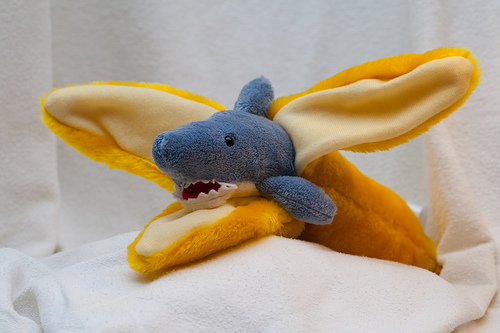<image>
Is there a shark in the banana? Yes. The shark is contained within or inside the banana, showing a containment relationship. Is there a banana in front of the shark? No. The banana is not in front of the shark. The spatial positioning shows a different relationship between these objects. 